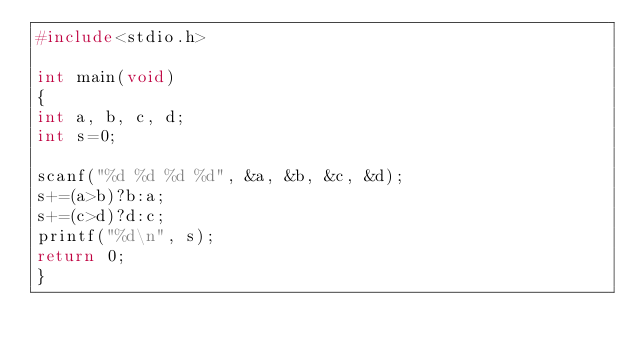Convert code to text. <code><loc_0><loc_0><loc_500><loc_500><_C_>#include<stdio.h>

int main(void)
{
int a, b, c, d;
int s=0;

scanf("%d %d %d %d", &a, &b, &c, &d);
s+=(a>b)?b:a;
s+=(c>d)?d:c;
printf("%d\n", s);
return 0;
}</code> 